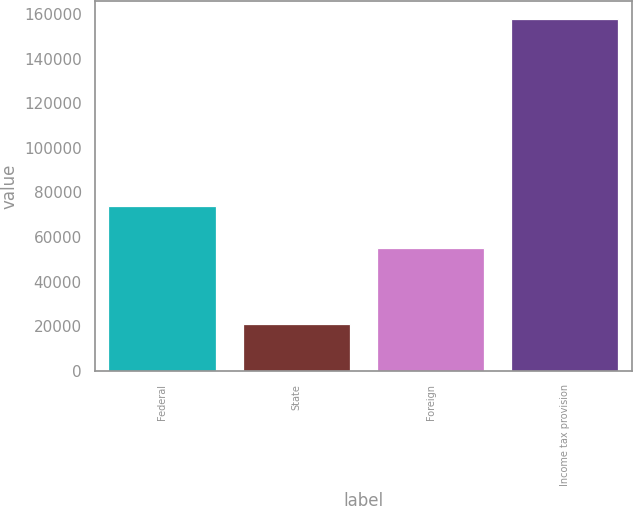<chart> <loc_0><loc_0><loc_500><loc_500><bar_chart><fcel>Federal<fcel>State<fcel>Foreign<fcel>Income tax provision<nl><fcel>73930<fcel>21216<fcel>55045<fcel>157955<nl></chart> 